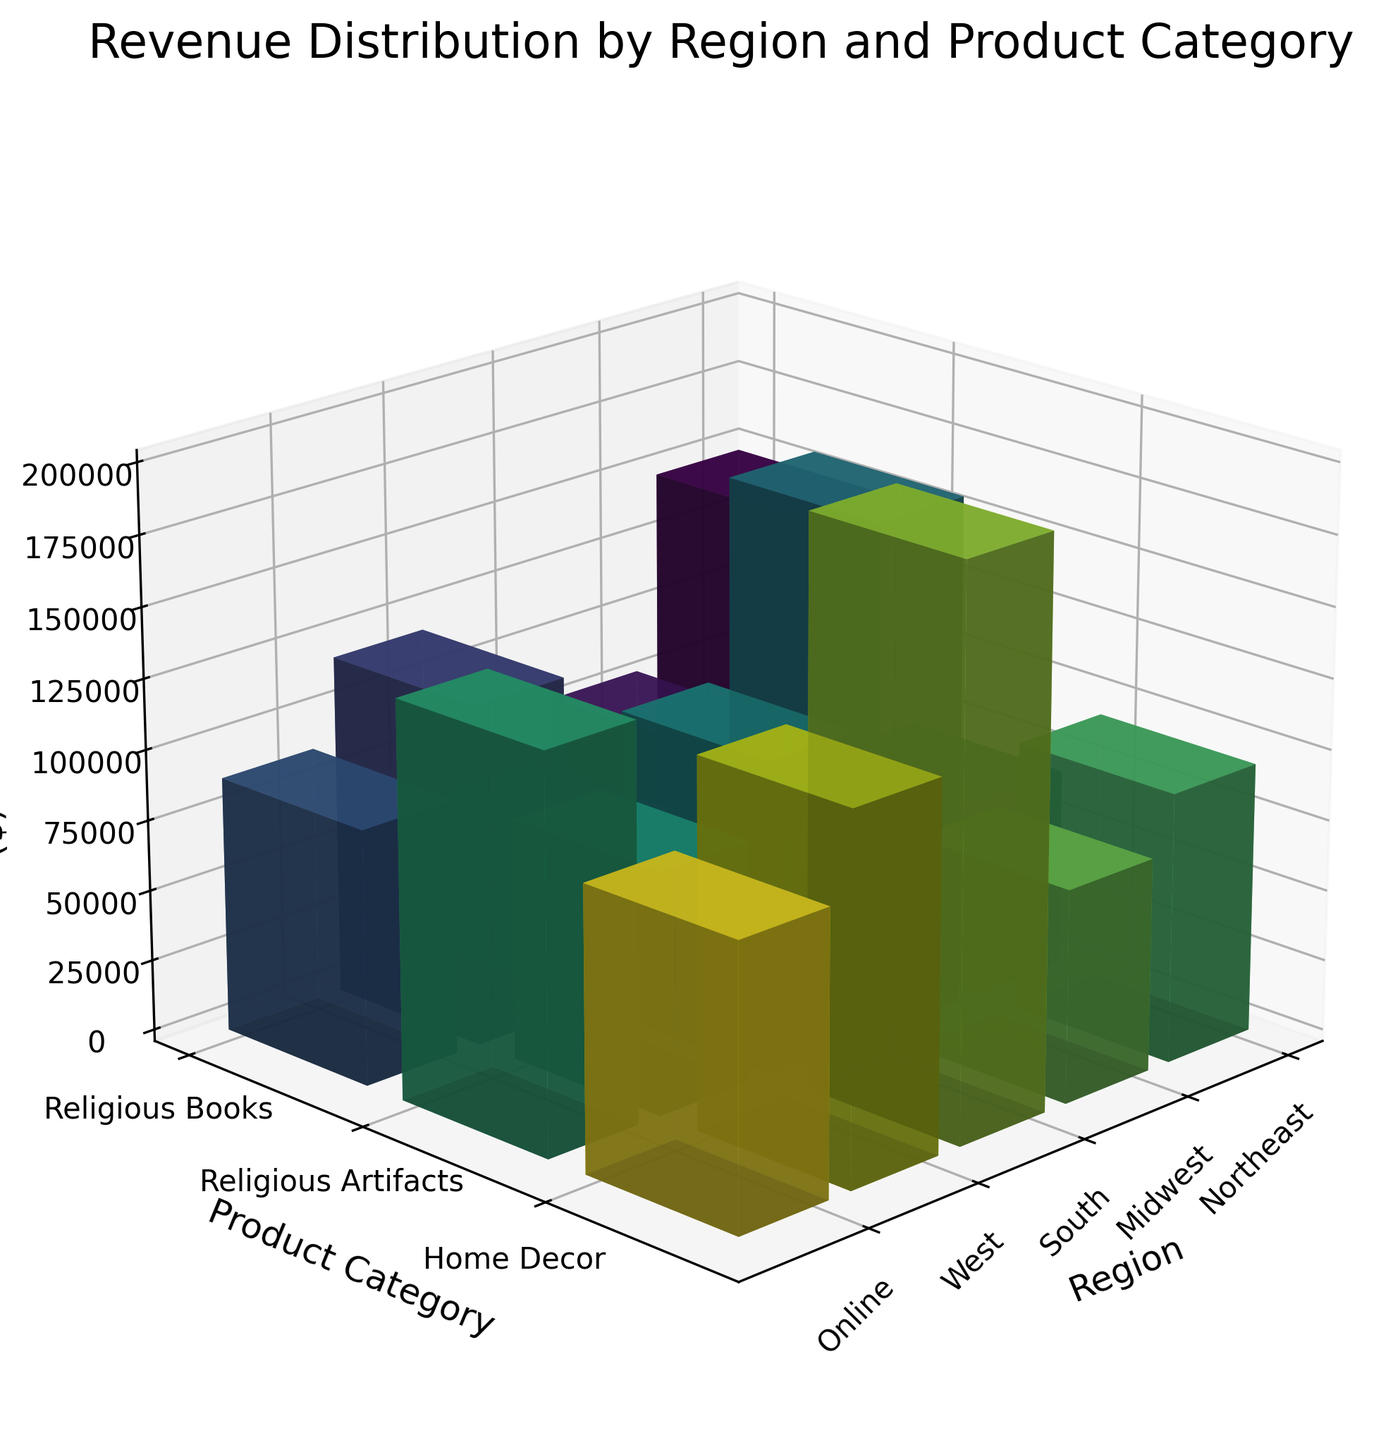What's the title of the plot? The title is found at the top of the figure and generally describes the content of the graph. In this case, it's related to revenue distribution by region and product category.
Answer: Revenue Distribution by Region and Product Category Which region has the highest revenue for Religious Books? By examining the heights of the 3D bars corresponding to Religious Books across all regions, the tallest bar represents the highest revenue, which appears under the 'Online' region category.
Answer: Online What is the total revenue for Home Decor across all regions? Summing up the revenues for Home Decor from each region: 60000 (Northeast) + 70000 (Midwest) + 85000 (South) + 75000 (West) + 100000 (Online) = 390000.
Answer: 390000 How does the revenue for Religious Artifacts in the South compare to the revenue for Religious Artifacts in the Midwest? By comparing the heights of the 3D bars for Religious Artifacts in the South and Midwest, the bar in the South appears taller, indicating higher revenue.
Answer: South has higher revenue Which product category has the highest average revenue across all regions? Calculate the average revenue for each product category: (150000 + 120000 + 180000 + 140000 + 200000)/5 = 158000 for Religious Books, (80000 + 90000 + 110000 + 95000 + 130000)/5 = 101000 for Religious Artifacts, and (60000 + 70000 + 85000 + 75000 + 100000)/5 = 78000 for Home Decor. The highest average is for Religious Books.
Answer: Religious Books Is the revenue for Home Decor in the Northeast more than the revenue for Religious Artifacts in the Northeast? By comparing the heights of the 3D bars for Home Decor and Religious Artifacts in the Northeast, it's evident that the bar for Religious Artifacts is taller.
Answer: No Which region has the lowest overall revenue across all product categories? Sum the revenues for each region and compare: Northeast (150000 + 80000 + 60000 = 290000), Midwest (120000 + 90000 + 70000 = 280000), South (180000 + 110000 + 85000 = 375000), West (140000 + 95000 + 75000 = 310000), Online (200000 + 130000 + 100000 = 430000). The Midwest has the lowest overall revenue.
Answer: Midwest How does the revenue for Religious Books in the West compare to the revenue for Home Decor in the Online category? Compare the heights of the 3D bars for Religious Books in the West and Home Decor in the Online category. The bar for Religious Books in the West (140000) is shorter than the one for Home Decor in the Online category (100000).
Answer: West has more revenue for Religious Books Which two regions have almost equal revenue for Religious Artifacts? By comparing the heights of the 3D bars for Religious Artifacts across all regions, the Midwest (90000) and West (95000) bars are closest in height, indicating nearly equal revenue.
Answer: Midwest and West What is the difference between the highest and lowest revenue among all product categories and regions? Determine the highest and lowest revenue values from the data: highest (200000 for Religious Books Online) and lowest (60000 for Home Decor Northeast). The difference is 200000 - 60000 = 140000.
Answer: 140000 